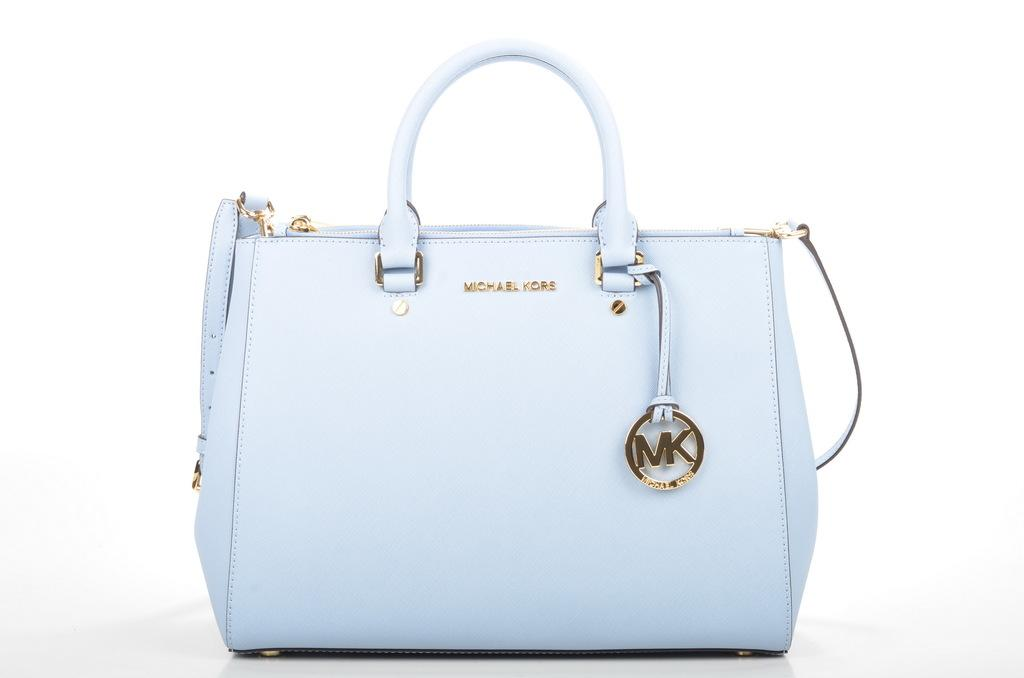What type of bag is visible in the image? There is a blue backpack in the image. What color is the backpack? The backpack is blue. What can be seen behind the backpack in the image? The background behind the backpack is white. Where is the clock located in the image? There is no clock present in the image. What type of throne can be seen in the image? There is no throne present in the image. 